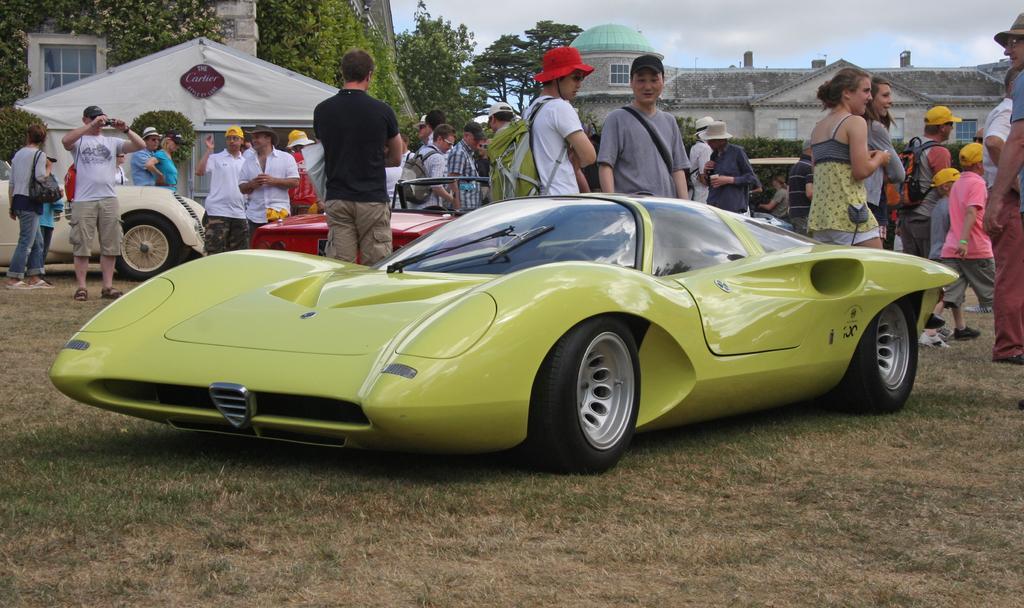Could you give a brief overview of what you see in this image? In this image we can see a car. On the ground there is grass. There are many people. Some are wearing caps. In the back there are other vehicles. Also there are buildings and trees. In the background there is sky. 